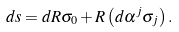<formula> <loc_0><loc_0><loc_500><loc_500>d s = d R \sigma _ { 0 } + R \left ( d \alpha ^ { j } \sigma _ { j } \right ) .</formula> 